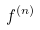Convert formula to latex. <formula><loc_0><loc_0><loc_500><loc_500>f ^ { ( n ) }</formula> 